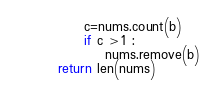<code> <loc_0><loc_0><loc_500><loc_500><_Python_>             c=nums.count(b)
             if c >1 :
                 nums.remove(b)
        return len(nums)

</code> 